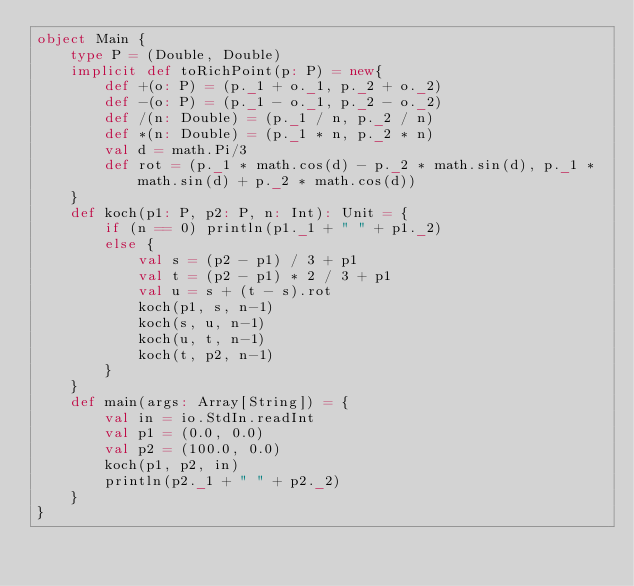Convert code to text. <code><loc_0><loc_0><loc_500><loc_500><_Scala_>object Main {
    type P = (Double, Double)
    implicit def toRichPoint(p: P) = new{ 
        def +(o: P) = (p._1 + o._1, p._2 + o._2)
        def -(o: P) = (p._1 - o._1, p._2 - o._2)
        def /(n: Double) = (p._1 / n, p._2 / n)
        def *(n: Double) = (p._1 * n, p._2 * n)
        val d = math.Pi/3
        def rot = (p._1 * math.cos(d) - p._2 * math.sin(d), p._1 * math.sin(d) + p._2 * math.cos(d))
    }
    def koch(p1: P, p2: P, n: Int): Unit = {
        if (n == 0) println(p1._1 + " " + p1._2)
        else {
            val s = (p2 - p1) / 3 + p1
            val t = (p2 - p1) * 2 / 3 + p1
            val u = s + (t - s).rot
            koch(p1, s, n-1)
            koch(s, u, n-1)
            koch(u, t, n-1)
            koch(t, p2, n-1)
        }
    }
    def main(args: Array[String]) = {
        val in = io.StdIn.readInt
        val p1 = (0.0, 0.0)
        val p2 = (100.0, 0.0)
        koch(p1, p2, in)
        println(p2._1 + " " + p2._2)
    }
}</code> 